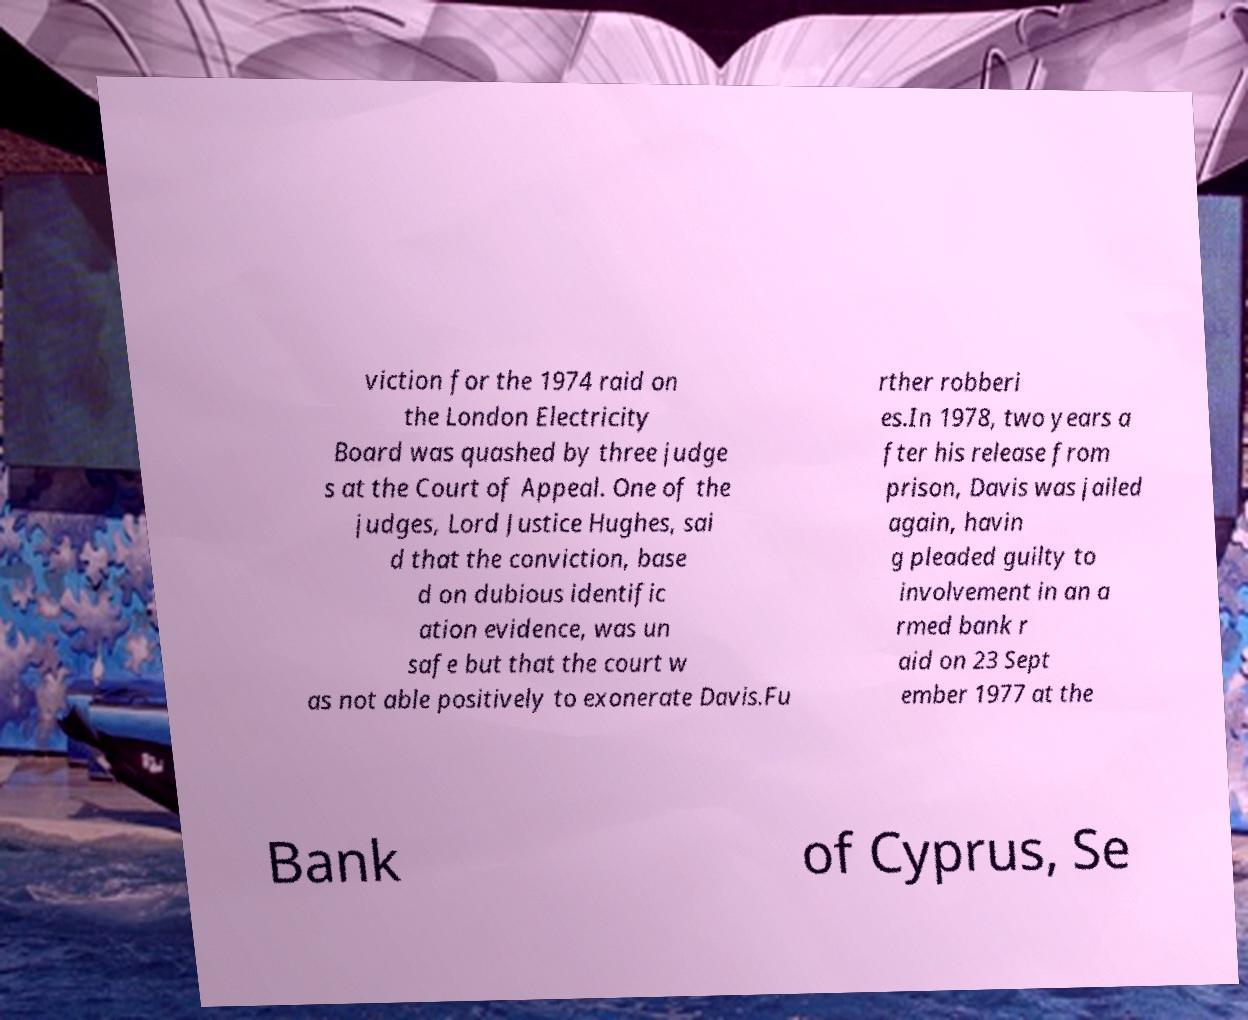I need the written content from this picture converted into text. Can you do that? viction for the 1974 raid on the London Electricity Board was quashed by three judge s at the Court of Appeal. One of the judges, Lord Justice Hughes, sai d that the conviction, base d on dubious identific ation evidence, was un safe but that the court w as not able positively to exonerate Davis.Fu rther robberi es.In 1978, two years a fter his release from prison, Davis was jailed again, havin g pleaded guilty to involvement in an a rmed bank r aid on 23 Sept ember 1977 at the Bank of Cyprus, Se 